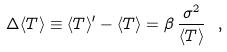<formula> <loc_0><loc_0><loc_500><loc_500>\Delta \langle T \rangle \equiv \langle T \rangle ^ { \prime } - \langle T \rangle = \beta \, \frac { \sigma ^ { 2 } } { \langle T \rangle } \ ,</formula> 